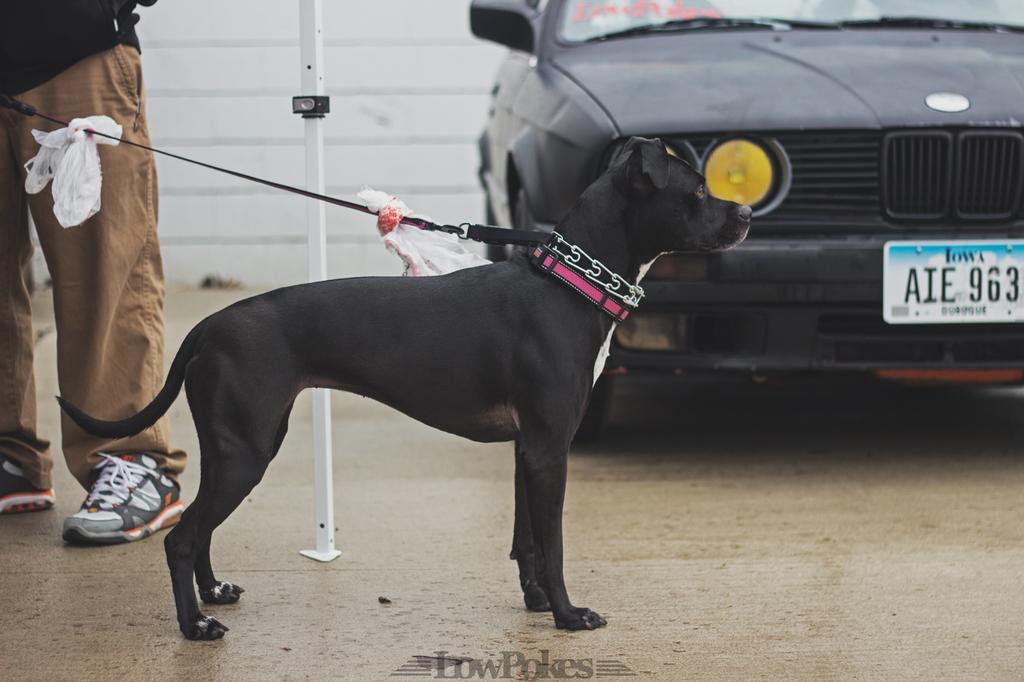In one or two sentences, can you explain what this image depicts? In this image we can see a black dog on the ground, here is the belt, there a person is standing, there a car is travelling on the road, here is the number plate, where is the pole. 